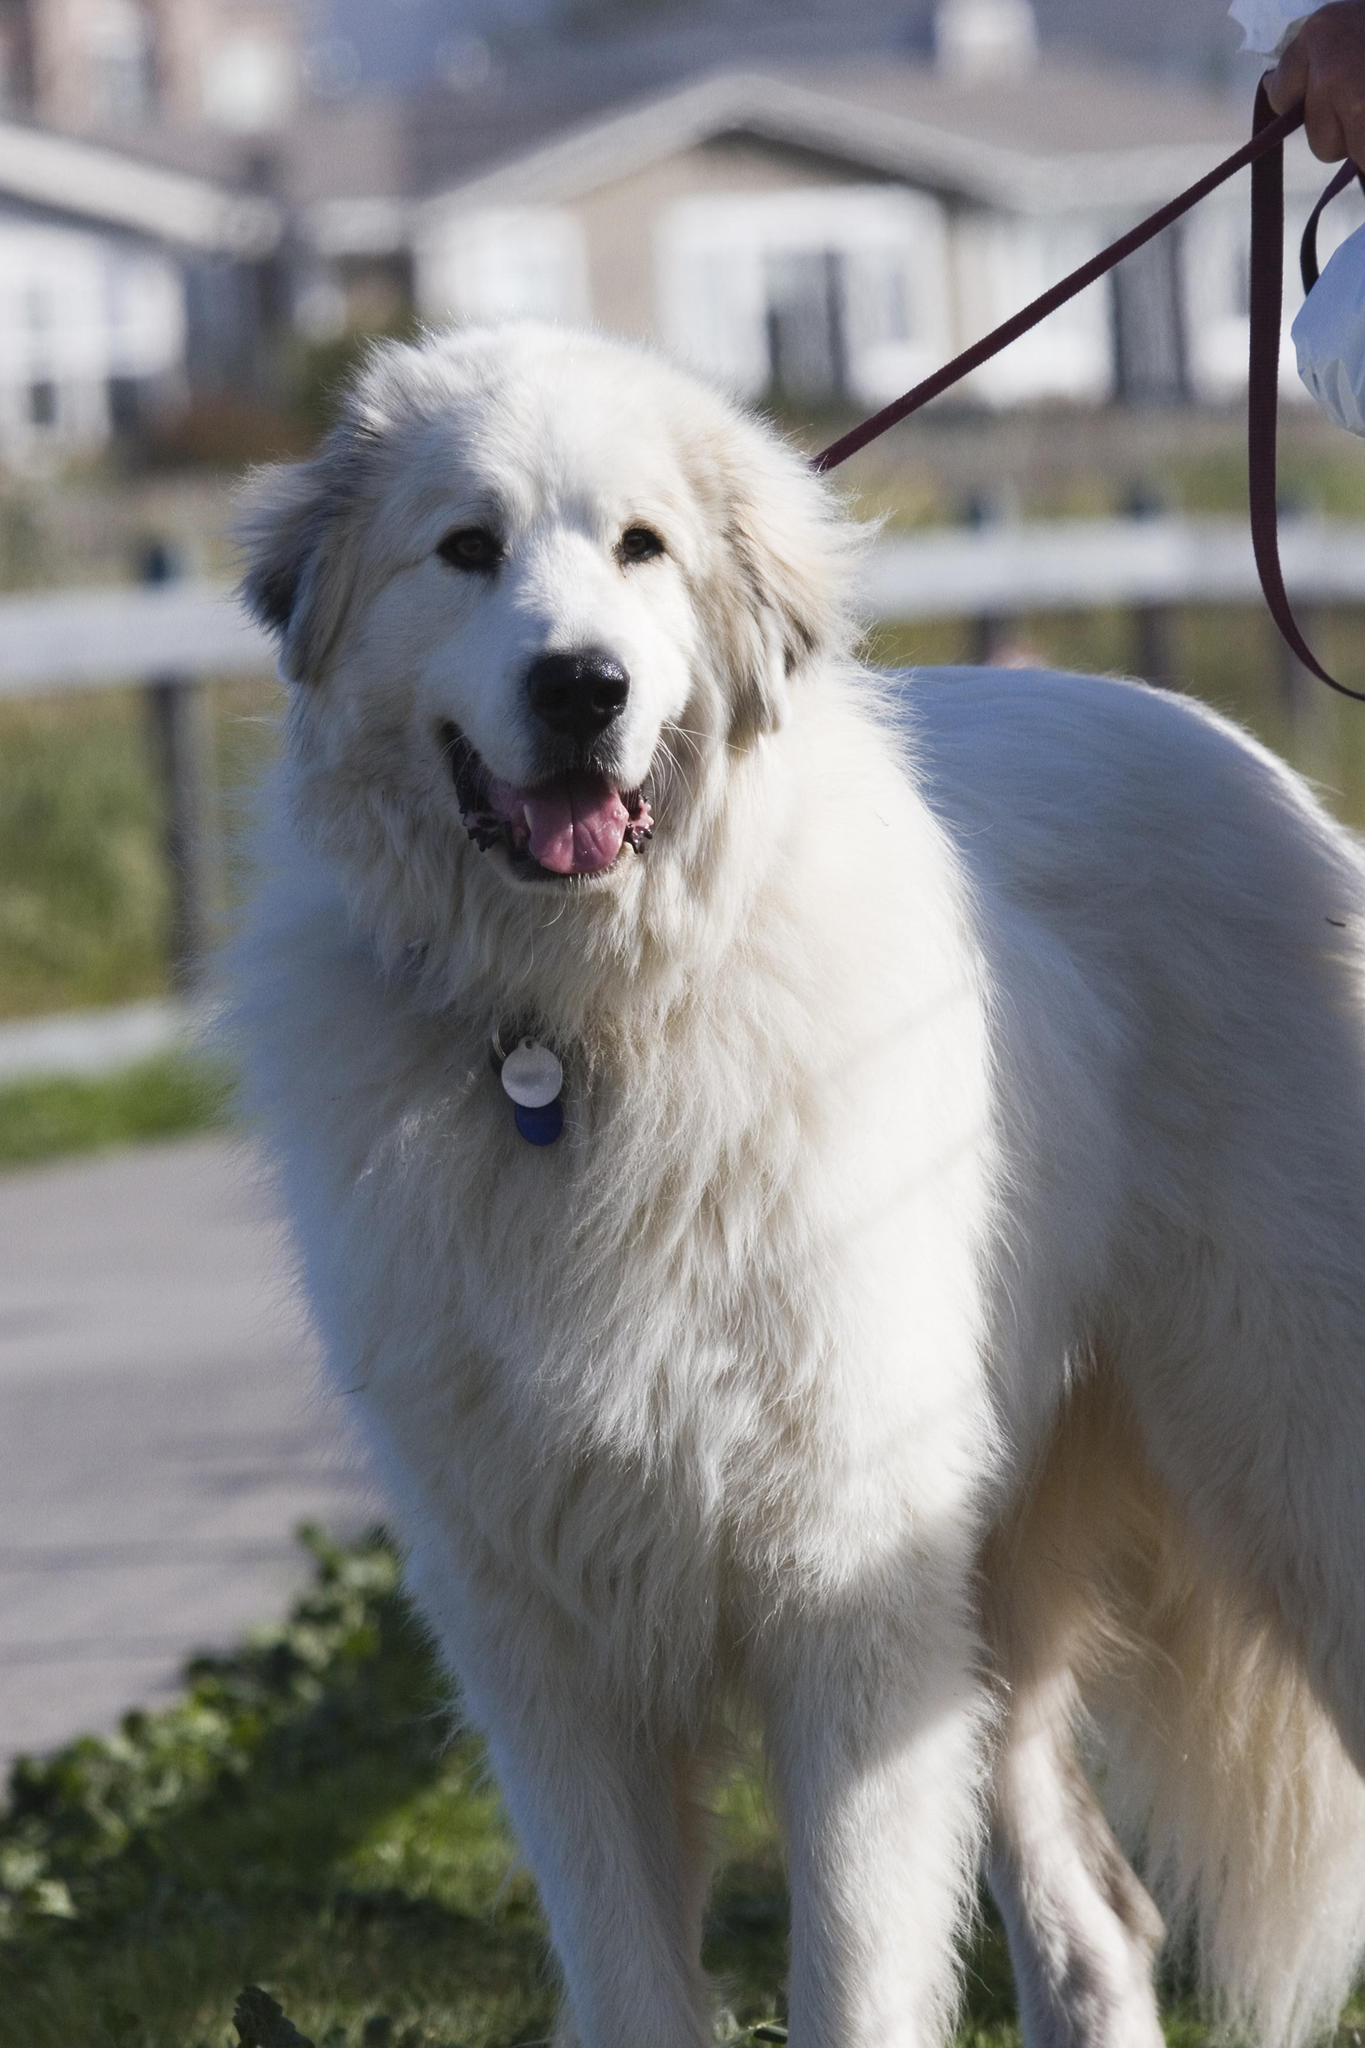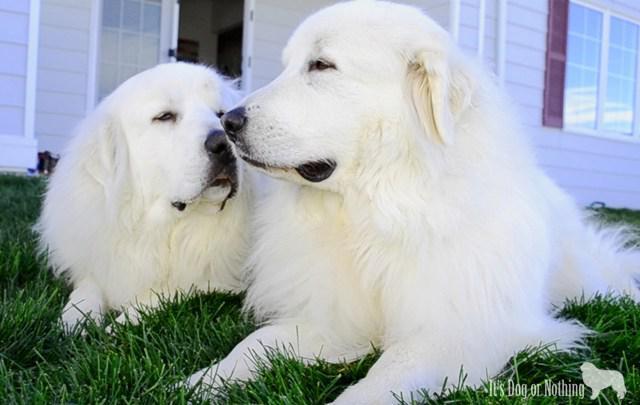The first image is the image on the left, the second image is the image on the right. Assess this claim about the two images: "There is a dog laying in the grass next to another dog". Correct or not? Answer yes or no. Yes. The first image is the image on the left, the second image is the image on the right. Examine the images to the left and right. Is the description "There are two dogs" accurate? Answer yes or no. No. 